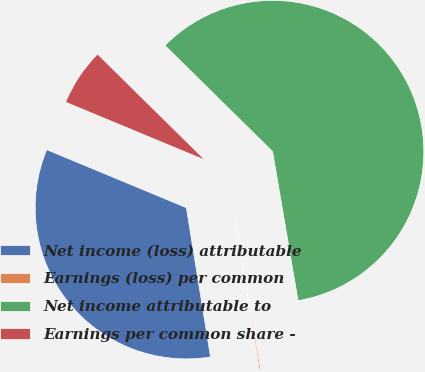<chart> <loc_0><loc_0><loc_500><loc_500><pie_chart><fcel>Net income (loss) attributable<fcel>Earnings (loss) per common<fcel>Net income attributable to<fcel>Earnings per common share -<nl><fcel>33.82%<fcel>0.14%<fcel>59.92%<fcel>6.12%<nl></chart> 